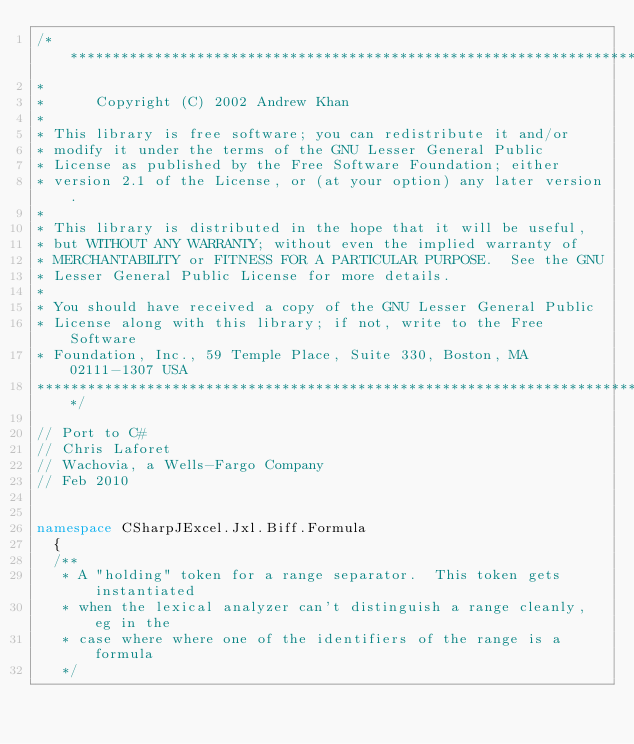<code> <loc_0><loc_0><loc_500><loc_500><_C#_>/*********************************************************************
*
*      Copyright (C) 2002 Andrew Khan
*
* This library is free software; you can redistribute it and/or
* modify it under the terms of the GNU Lesser General Public
* License as published by the Free Software Foundation; either
* version 2.1 of the License, or (at your option) any later version.
*
* This library is distributed in the hope that it will be useful,
* but WITHOUT ANY WARRANTY; without even the implied warranty of
* MERCHANTABILITY or FITNESS FOR A PARTICULAR PURPOSE.  See the GNU
* Lesser General Public License for more details.
*
* You should have received a copy of the GNU Lesser General Public
* License along with this library; if not, write to the Free Software
* Foundation, Inc., 59 Temple Place, Suite 330, Boston, MA 02111-1307 USA
***************************************************************************/

// Port to C# 
// Chris Laforet
// Wachovia, a Wells-Fargo Company
// Feb 2010


namespace CSharpJExcel.Jxl.Biff.Formula
	{
	/**
	 * A "holding" token for a range separator.  This token gets instantiated
	 * when the lexical analyzer can't distinguish a range cleanly, eg in the
	 * case where where one of the identifiers of the range is a formula
	 */</code> 